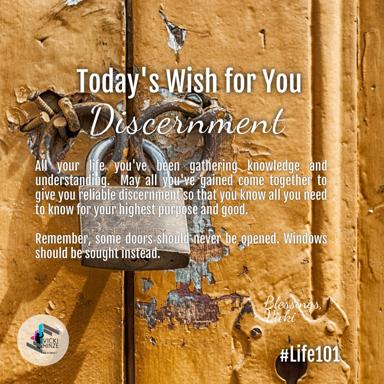Can you draw a parallel between the concept of discernment in the image and a real-life decision-making scenario? Similar to the advice in the image, when faced with career choices, one might encounter certain paths (doors) that appear promising but have underlying challenges. Instead of advancing through these troublesome doors, one can explore alternative paths (windows), such as additional training or alternative roles, which may lead to more significant growth and suitability in the long term. 